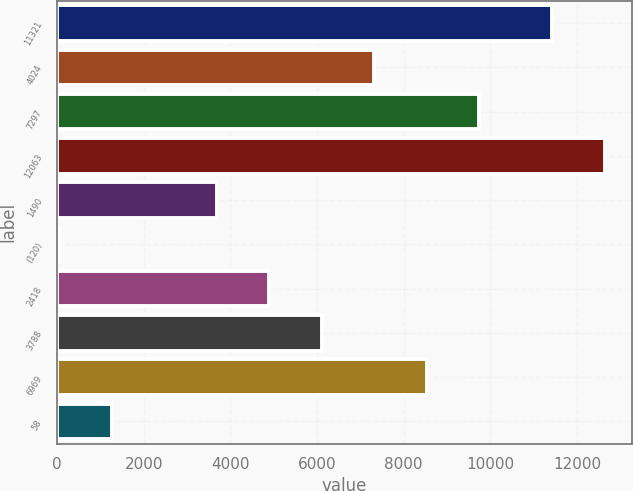<chart> <loc_0><loc_0><loc_500><loc_500><bar_chart><fcel>11321<fcel>4024<fcel>7297<fcel>12063<fcel>1490<fcel>(120)<fcel>2418<fcel>3788<fcel>6969<fcel>58<nl><fcel>11427<fcel>7317.8<fcel>9736.4<fcel>12636.3<fcel>3689.9<fcel>62<fcel>4899.2<fcel>6108.5<fcel>8527.1<fcel>1271.3<nl></chart> 